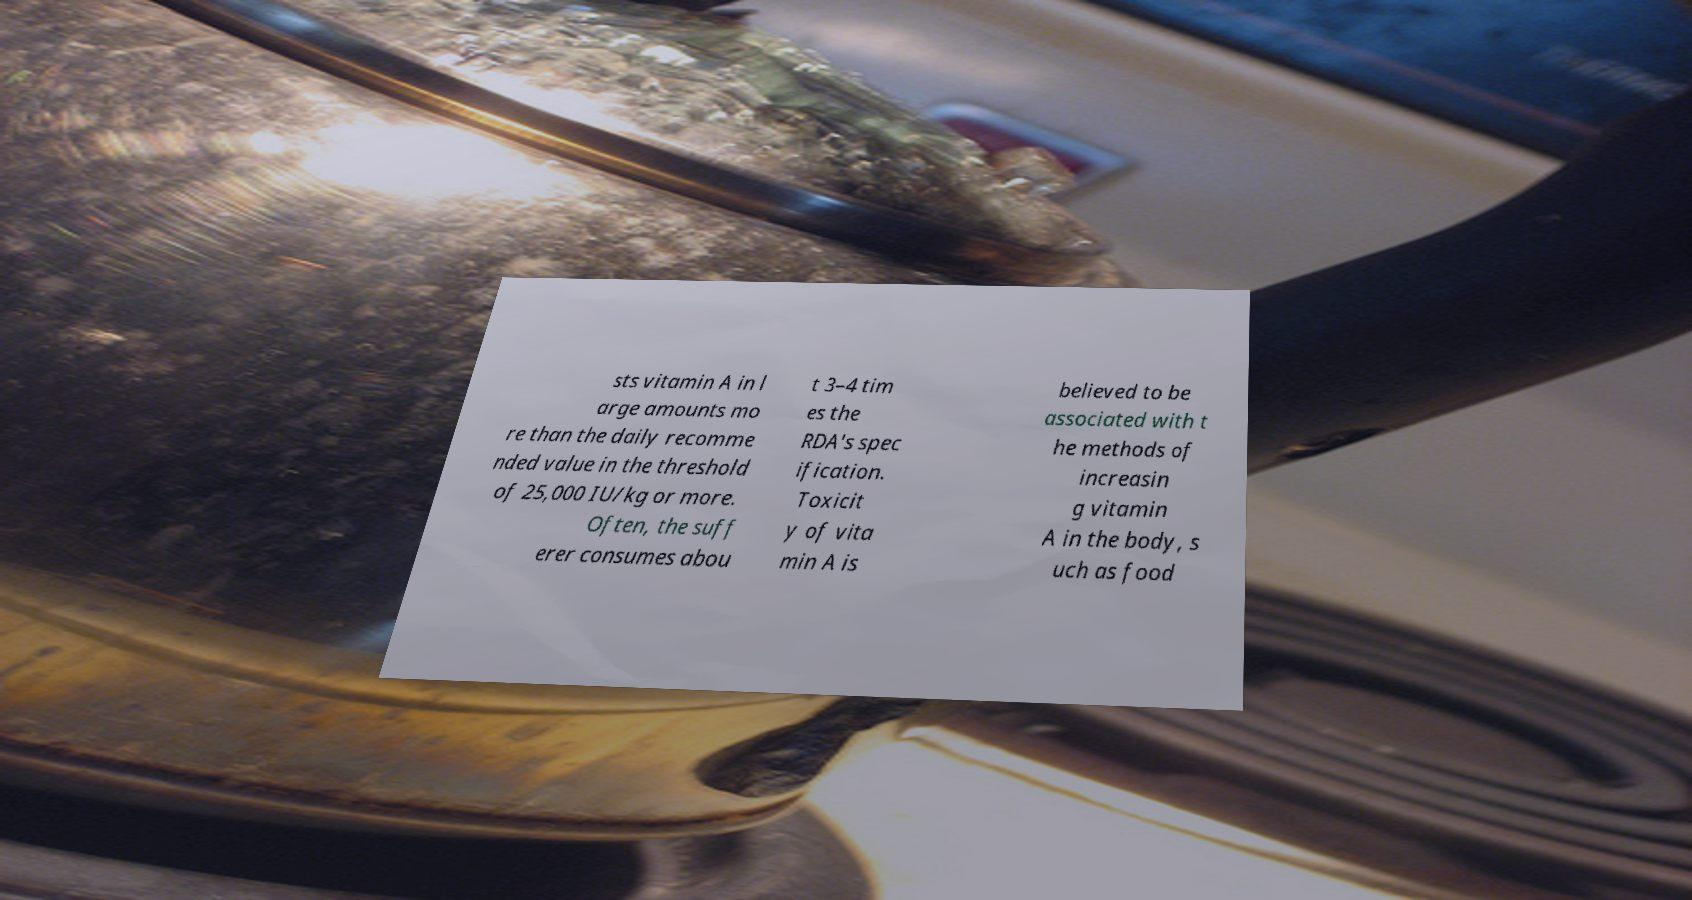Please identify and transcribe the text found in this image. sts vitamin A in l arge amounts mo re than the daily recomme nded value in the threshold of 25,000 IU/kg or more. Often, the suff erer consumes abou t 3–4 tim es the RDA's spec ification. Toxicit y of vita min A is believed to be associated with t he methods of increasin g vitamin A in the body, s uch as food 